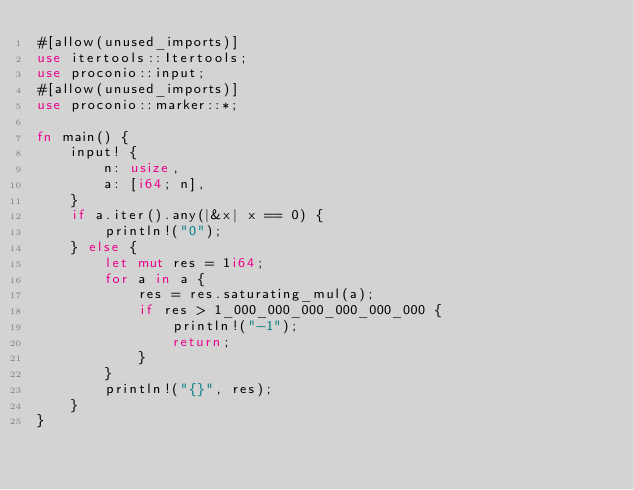Convert code to text. <code><loc_0><loc_0><loc_500><loc_500><_Rust_>#[allow(unused_imports)]
use itertools::Itertools;
use proconio::input;
#[allow(unused_imports)]
use proconio::marker::*;

fn main() {
    input! {
        n: usize,
        a: [i64; n],
    }
    if a.iter().any(|&x| x == 0) {
        println!("0");
    } else {
        let mut res = 1i64;
        for a in a {
            res = res.saturating_mul(a);
            if res > 1_000_000_000_000_000_000 {
                println!("-1");
                return;
            }
        }
        println!("{}", res);
    }
}
</code> 